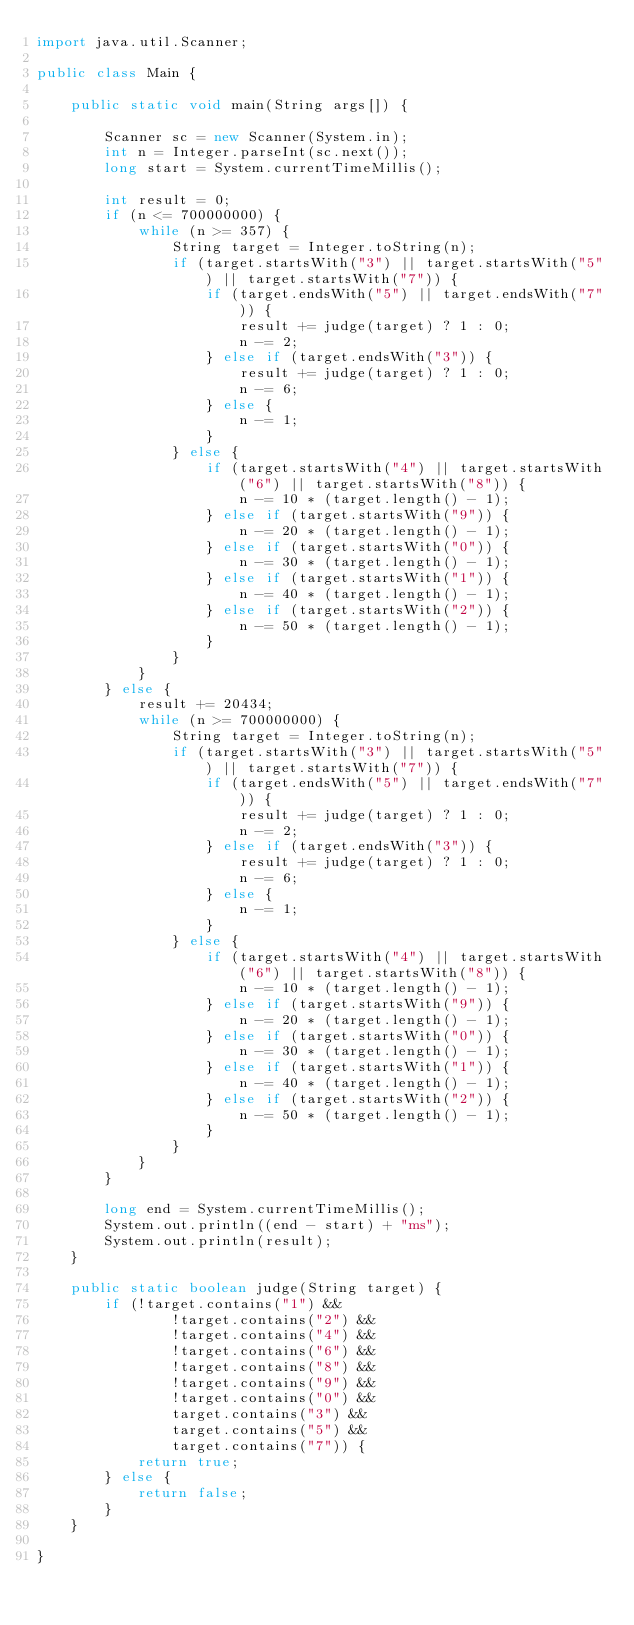<code> <loc_0><loc_0><loc_500><loc_500><_Java_>import java.util.Scanner;

public class Main {

    public static void main(String args[]) {

        Scanner sc = new Scanner(System.in);
        int n = Integer.parseInt(sc.next());
        long start = System.currentTimeMillis();

        int result = 0;
        if (n <= 700000000) {
            while (n >= 357) {
                String target = Integer.toString(n);
                if (target.startsWith("3") || target.startsWith("5") || target.startsWith("7")) {
                    if (target.endsWith("5") || target.endsWith("7")) {
                        result += judge(target) ? 1 : 0;
                        n -= 2;
                    } else if (target.endsWith("3")) {
                        result += judge(target) ? 1 : 0;
                        n -= 6;
                    } else {
                        n -= 1;
                    }
                } else {
                    if (target.startsWith("4") || target.startsWith("6") || target.startsWith("8")) {
                        n -= 10 * (target.length() - 1);
                    } else if (target.startsWith("9")) {
                        n -= 20 * (target.length() - 1);
                    } else if (target.startsWith("0")) {
                        n -= 30 * (target.length() - 1);
                    } else if (target.startsWith("1")) {
                        n -= 40 * (target.length() - 1);
                    } else if (target.startsWith("2")) {
                        n -= 50 * (target.length() - 1);
                    }
                }
            }
        } else {
            result += 20434;
            while (n >= 700000000) {
                String target = Integer.toString(n);
                if (target.startsWith("3") || target.startsWith("5") || target.startsWith("7")) {
                    if (target.endsWith("5") || target.endsWith("7")) {
                        result += judge(target) ? 1 : 0;
                        n -= 2;
                    } else if (target.endsWith("3")) {
                        result += judge(target) ? 1 : 0;
                        n -= 6;
                    } else {
                        n -= 1;
                    }
                } else {
                    if (target.startsWith("4") || target.startsWith("6") || target.startsWith("8")) {
                        n -= 10 * (target.length() - 1);
                    } else if (target.startsWith("9")) {
                        n -= 20 * (target.length() - 1);
                    } else if (target.startsWith("0")) {
                        n -= 30 * (target.length() - 1);
                    } else if (target.startsWith("1")) {
                        n -= 40 * (target.length() - 1);
                    } else if (target.startsWith("2")) {
                        n -= 50 * (target.length() - 1);
                    }
                }
            }
        }

        long end = System.currentTimeMillis();
        System.out.println((end - start) + "ms");
        System.out.println(result);
    }

    public static boolean judge(String target) {
        if (!target.contains("1") &&
                !target.contains("2") &&
                !target.contains("4") &&
                !target.contains("6") &&
                !target.contains("8") &&
                !target.contains("9") &&
                !target.contains("0") &&
                target.contains("3") &&
                target.contains("5") &&
                target.contains("7")) {
            return true;
        } else {
            return false;
        }
    }

}</code> 